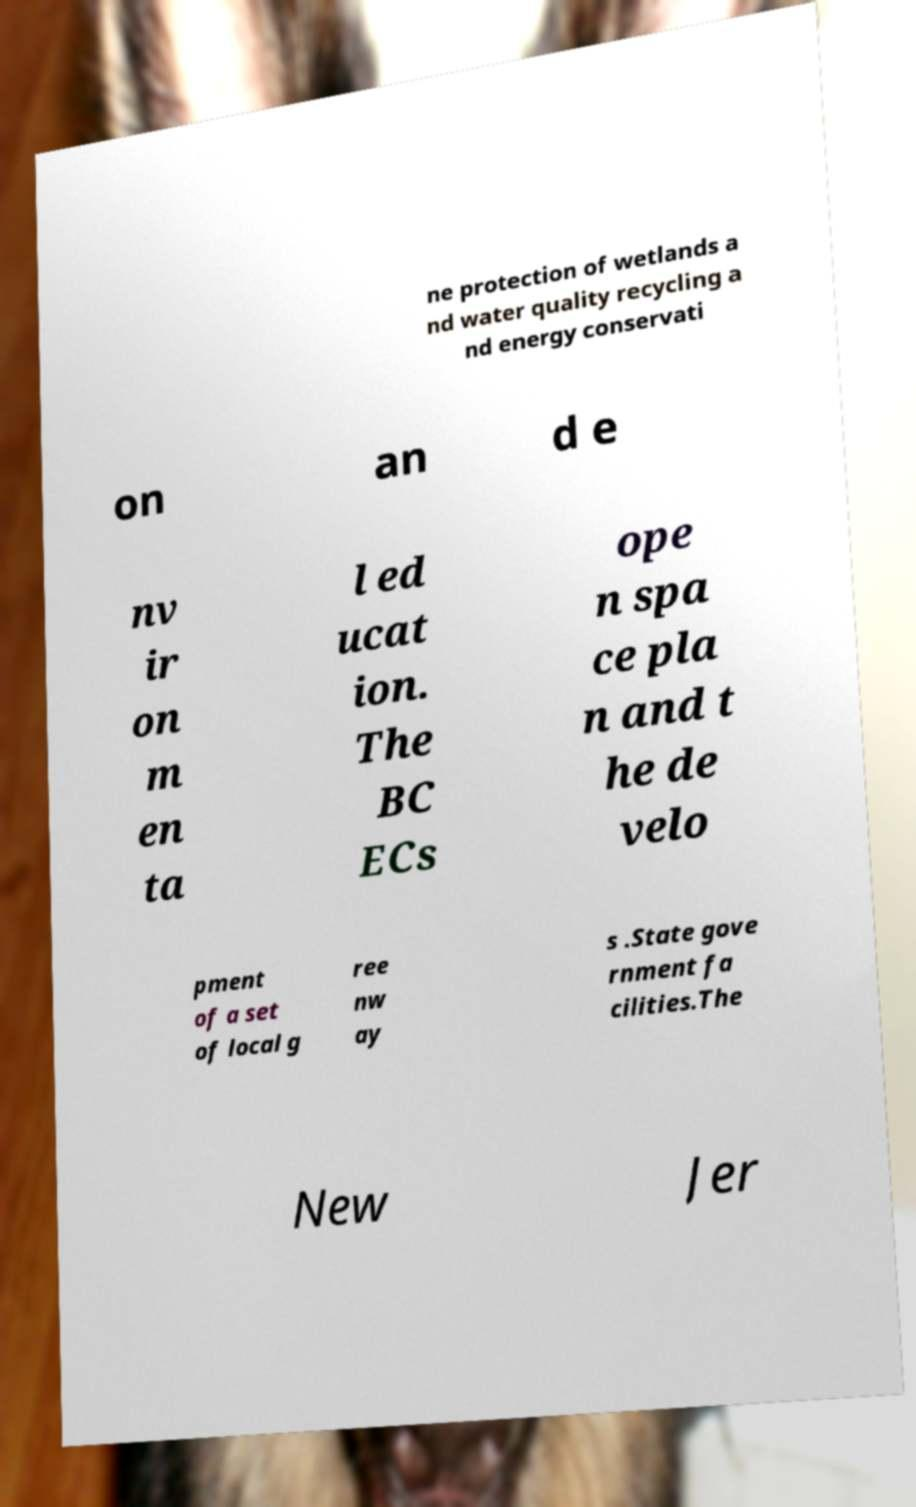Could you assist in decoding the text presented in this image and type it out clearly? ne protection of wetlands a nd water quality recycling a nd energy conservati on an d e nv ir on m en ta l ed ucat ion. The BC ECs ope n spa ce pla n and t he de velo pment of a set of local g ree nw ay s .State gove rnment fa cilities.The New Jer 